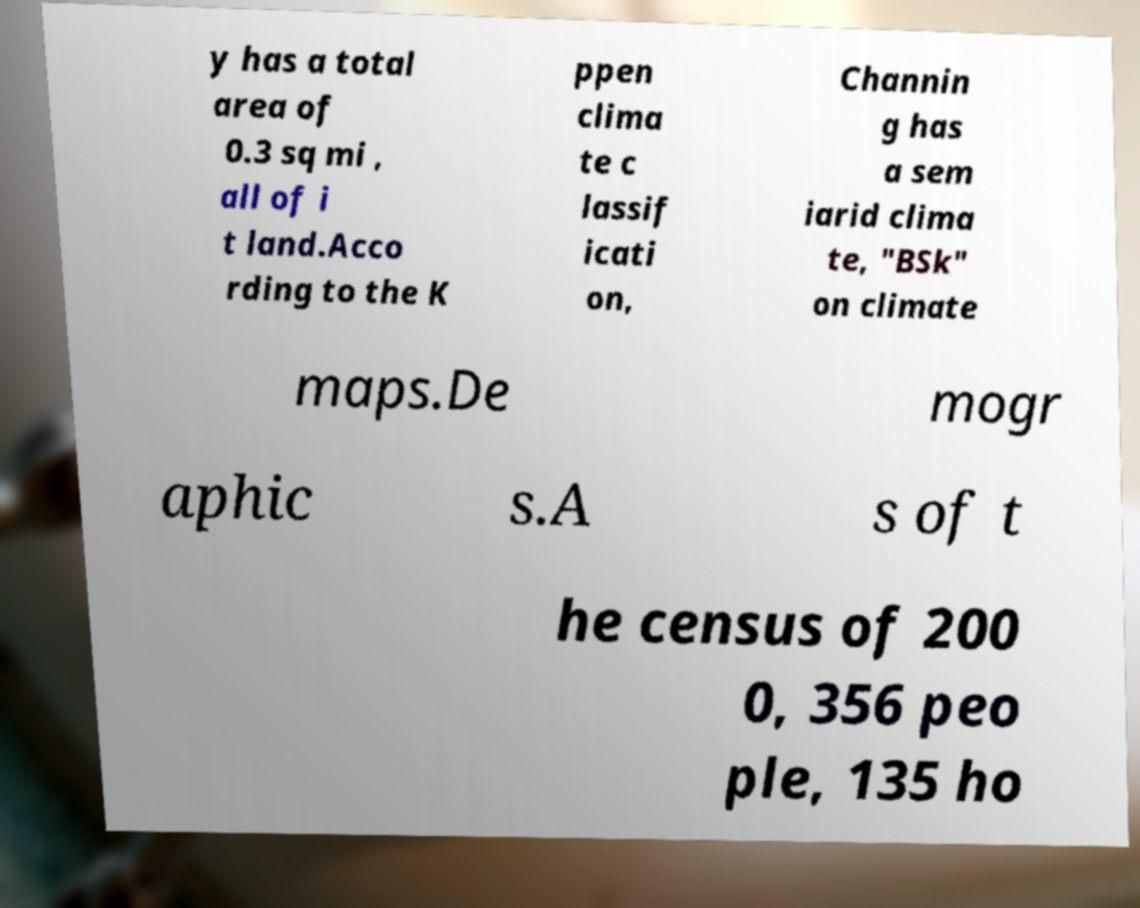For documentation purposes, I need the text within this image transcribed. Could you provide that? y has a total area of 0.3 sq mi , all of i t land.Acco rding to the K ppen clima te c lassif icati on, Channin g has a sem iarid clima te, "BSk" on climate maps.De mogr aphic s.A s of t he census of 200 0, 356 peo ple, 135 ho 